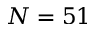Convert formula to latex. <formula><loc_0><loc_0><loc_500><loc_500>N = 5 1</formula> 